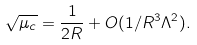<formula> <loc_0><loc_0><loc_500><loc_500>\sqrt { \mu _ { c } } = { \frac { 1 } { 2 R } } + O ( 1 / R ^ { 3 } \Lambda ^ { 2 } ) .</formula> 